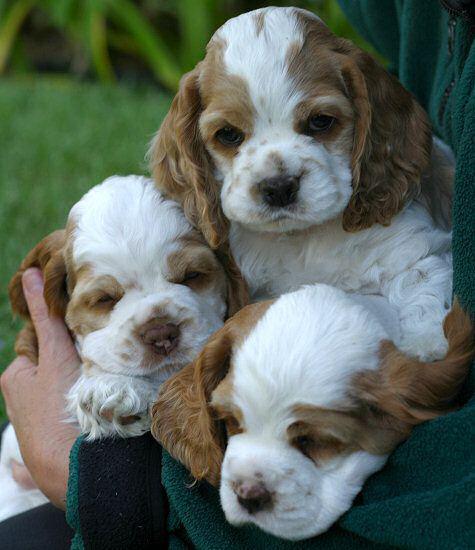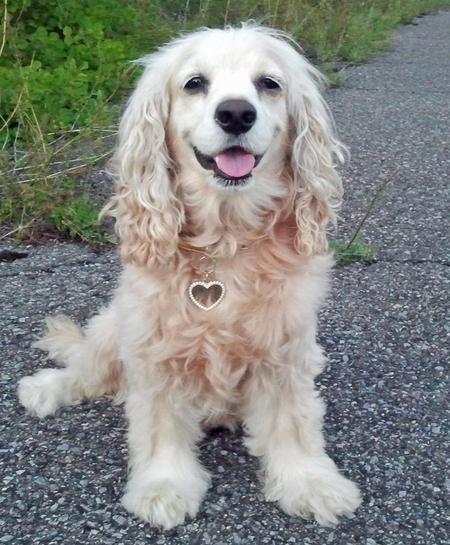The first image is the image on the left, the second image is the image on the right. For the images displayed, is the sentence "The left image shows no less than three spaniel puppies, and the right image shows just one spaniel sitting" factually correct? Answer yes or no. Yes. The first image is the image on the left, the second image is the image on the right. Examine the images to the left and right. Is the description "The left image contains at least three dogs." accurate? Answer yes or no. Yes. 